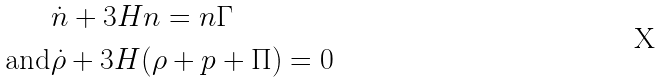Convert formula to latex. <formula><loc_0><loc_0><loc_500><loc_500>& \dot { n } + 3 H n = n \Gamma \\ \text {and} & \dot { \rho } + 3 H ( \rho + p + \Pi ) = 0</formula> 